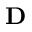Convert formula to latex. <formula><loc_0><loc_0><loc_500><loc_500>D</formula> 